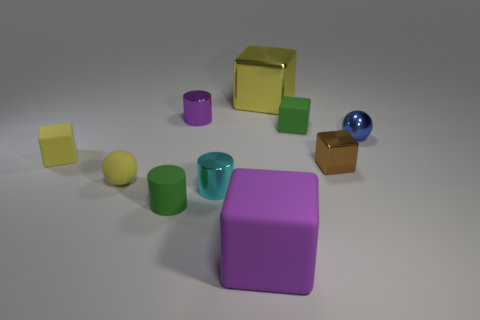There is a purple thing in front of the purple cylinder; is its size the same as the small green cylinder? no 